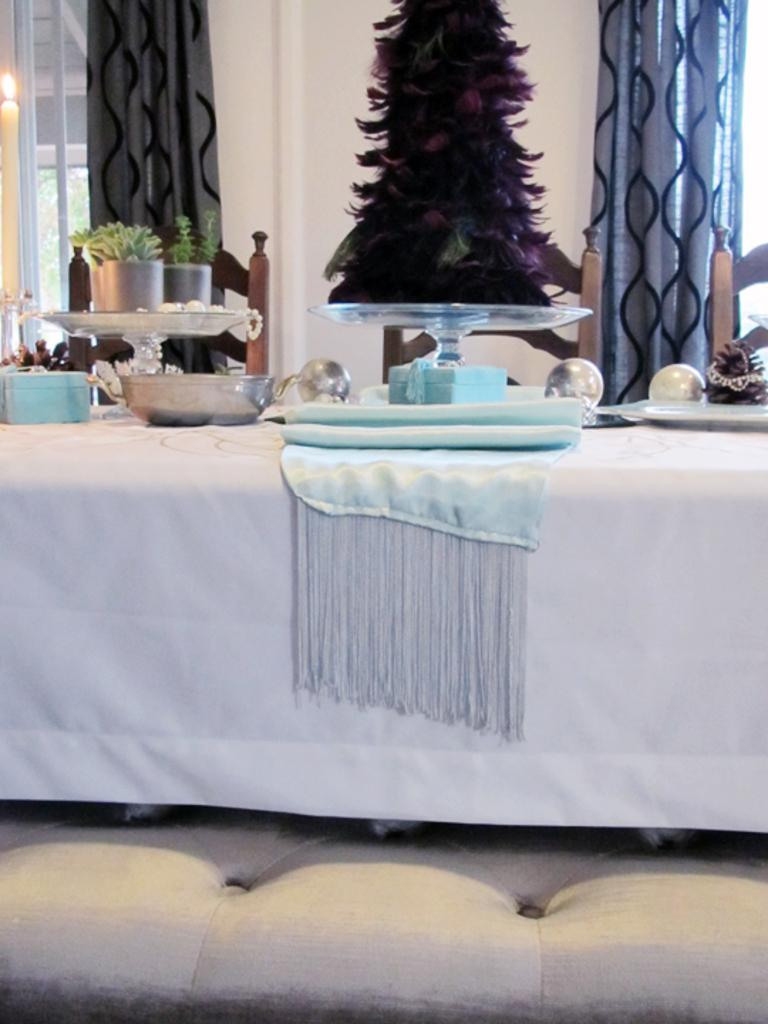What type of furniture is present in the image? There are chairs, a table, and a couch in the image. What is on the table in the image? There is a cloth, bowls, a box, and balls on the table in the image. What can be seen in the background of the image? There are plants, stands, windows, curtains, and a wall visible in the image. What invention is being demonstrated in the image? There is no invention being demonstrated in the image; it features furniture and other objects in a room. Can you see a beetle crawling on the wall in the image? There is no beetle visible in the image; only the plants, stands, windows, curtains, and wall are present. 